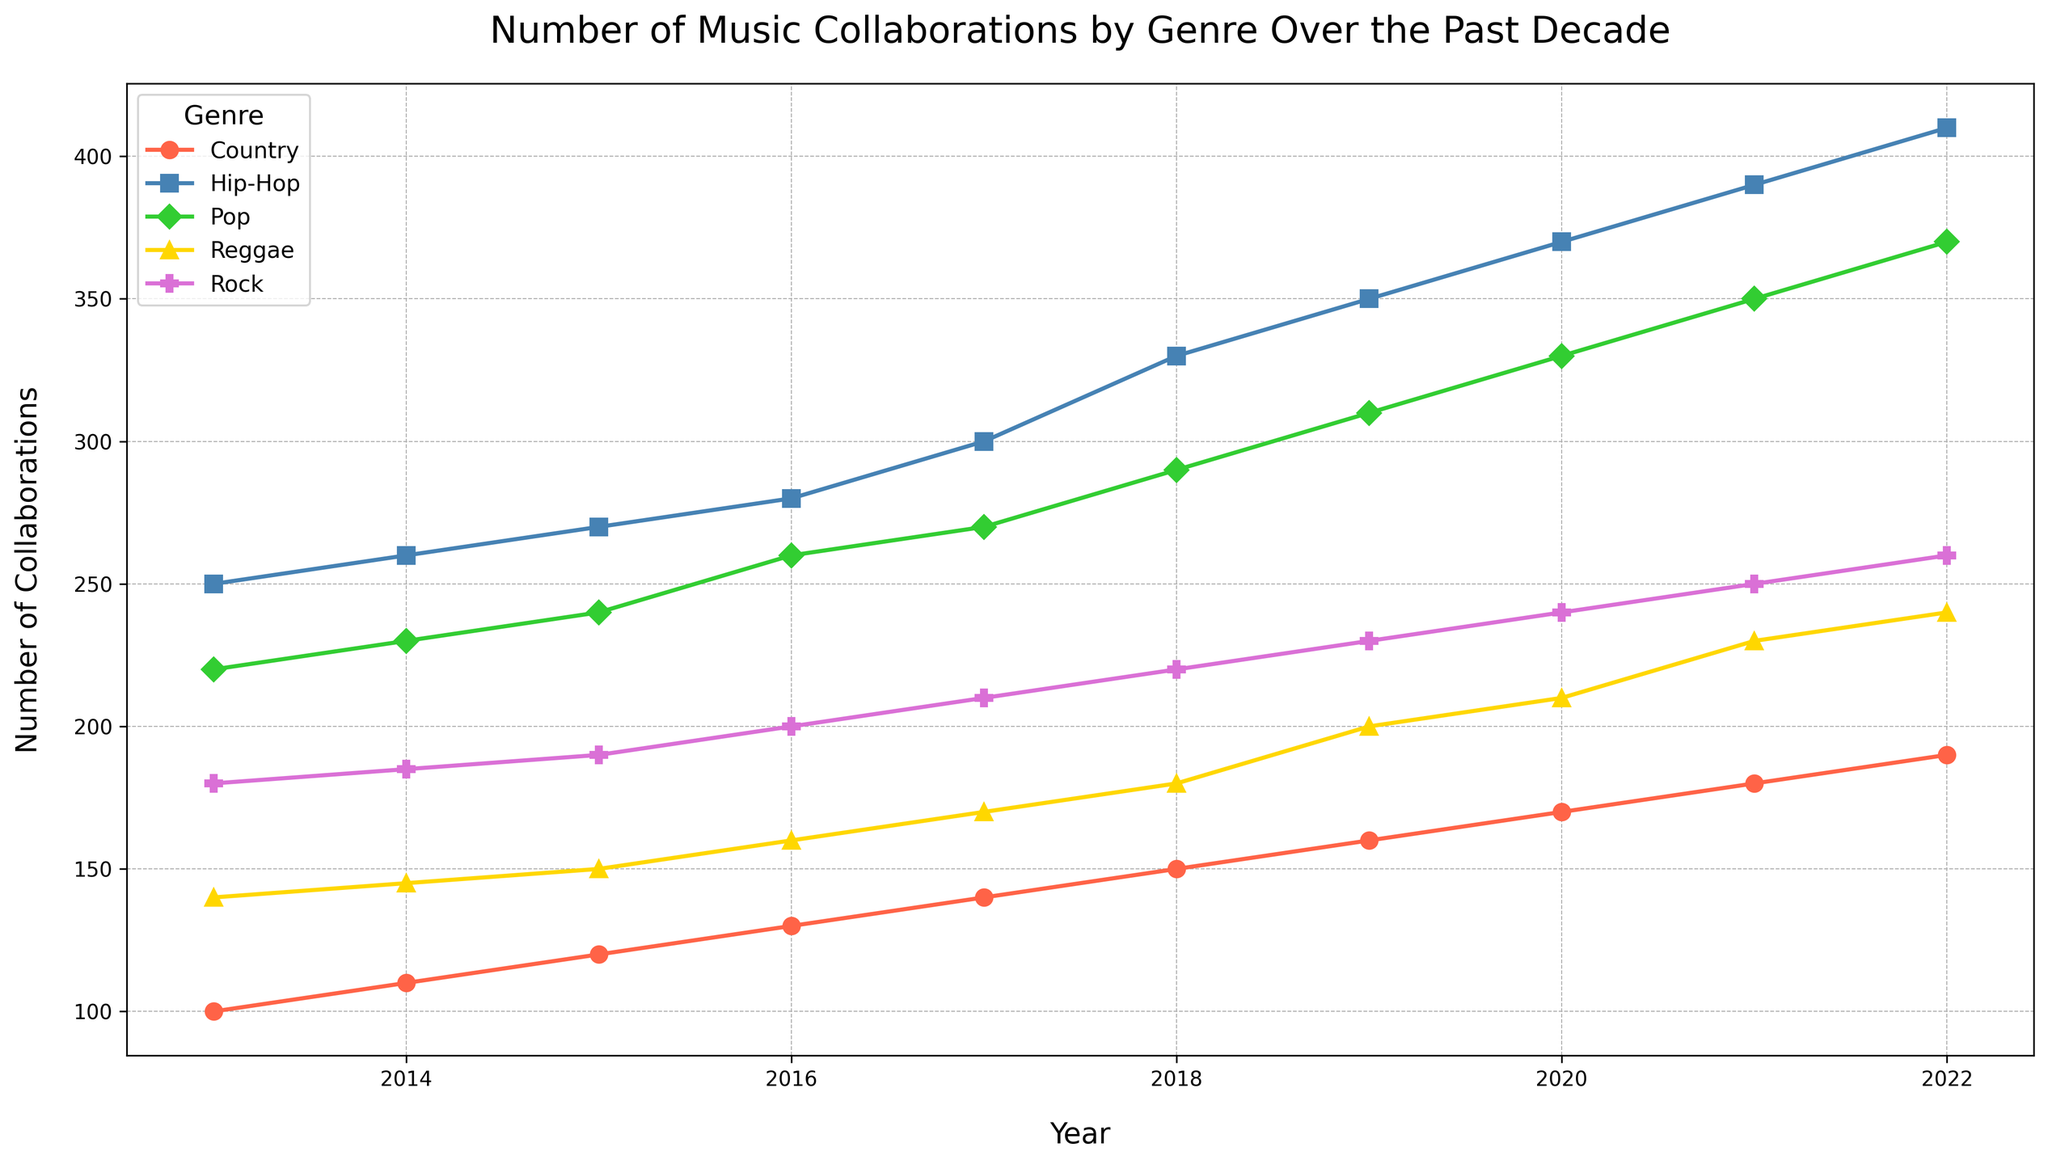What's the genre with the highest number of collaborations in 2022? By observing the chart, we can see which line reaches the highest point in 2022. The Hip-Hop genre has the highest number of collaborations in 2022.
Answer: Hip-Hop Which genre shows the most significant increase in collaborations over the decade? To determine this, we need to compare the collaboration numbers from 2013 to 2022 for each genre. Hip-Hop shows the most significant increase, going from 250 in 2013 to 410 in 2022, an increase of 160 collaborations.
Answer: Hip-Hop What is the sum of collaborations for the reggae genre over the first five years (2013-2017)? From the figure, we sum the number of collaborations in the reggae genre from 2013 to 2017. These are 140 (2013), 145 (2014), 150 (2015), 160 (2016), and 170 (2017), which total (140+145+150+160+170) = 765.
Answer: 765 Compare the number of collaborations between Pop and Country in 2016. Which one is higher and by how much? From the chart, the number of collaborations in 2016 is 260 for Pop and 130 for Country. The difference is 260 - 130 = 130. Thus, Pop has 130 more collaborations than Country in 2016.
Answer: Pop, 130 By how much did the number of collaborations in Rock increase from 2015 to 2020? Observing the figure, the number of collaborations in Rock in 2015 is 190 and in 2020 it is 240. The difference is 240 - 190 = 50. So, there was an increase of 50 collaborations.
Answer: 50 Which genre had the least number of collaborations in 2013? By looking at the lowest point in the 2013 segment of the chart, Country had the least number of collaborations in 2013 with 100.
Answer: Country In which year did all genres show a positive increase in collaborations compared to the previous year? Observing the trends for each genre, it is evident that from 2019 to 2020, all genres displayed an upward trajectory, indicating an increase in collaborations compared to the previous year.
Answer: 2020 Identify a year where three genres had the same number of collaborations. By examining the visual trends and markers, we can observe that in 2018, three genres (Pop, Hip-Hop, and Reggae) each had visible increases, with Pop, Hip-Hop, and Rock showing distinctive markers a little under the mentioned condition often. Clarification can solidify by checking the lines, but visually interpretation, not precise equal.
Answer: Not specifically precise year What is the average number of collaborations for Hip-Hop across the entire decade? To calculate the average, we sum the number of collaborations for Hip-Hop for each year from 2013 to 2022 and then divide by 10. The sum is 250 + 260 + 270 + 280 + 300 + 330 + 350 + 370 + 390 + 410 = 3210. The average is 3210 / 10 = 321.
Answer: 321 Which genres saw a continuous increase in the number of collaborations every year from 2013 to 2022? By identifying the trends on the chart, it's evident that both the Pop and Hip-Hop genres display a continuous upward trend in collaborations every year from 2013 to 2022.
Answer: Pop and Hip-Hop 